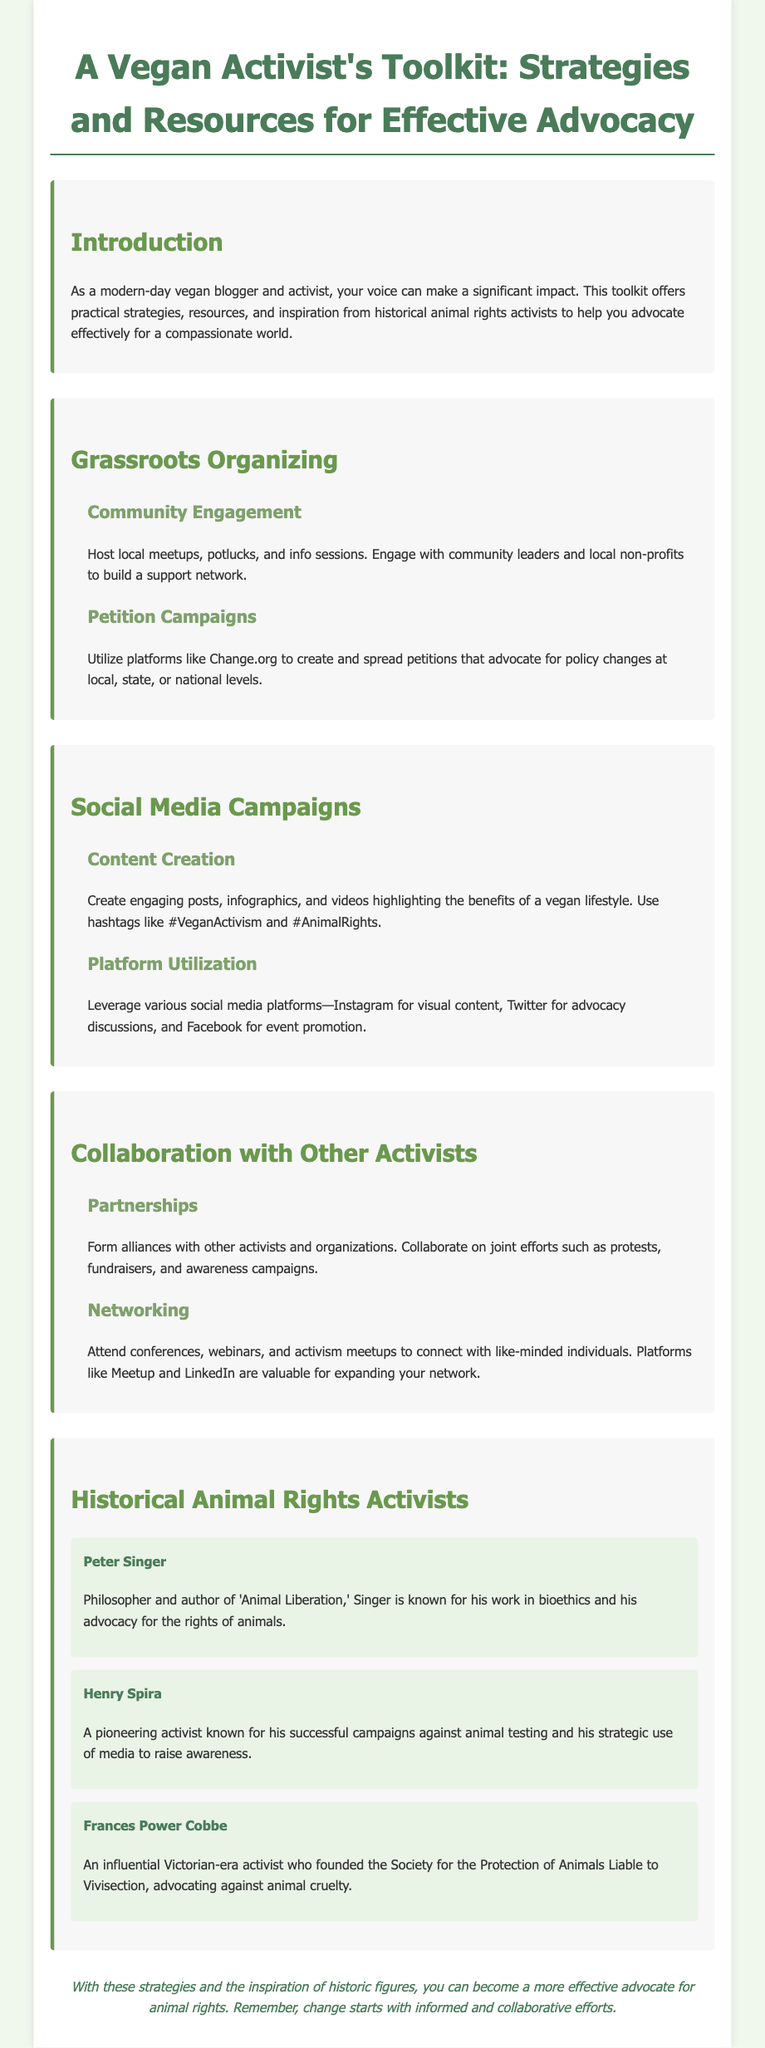What is the title of the toolkit? The title of the toolkit is presented in the main heading of the document.
Answer: A Vegan Activist's Toolkit: Strategies and Resources for Effective Advocacy Who is a noted philosopher associated with animal rights? The document lists Peter Singer as a significant figure advocating for animal rights.
Answer: Peter Singer What are two social media platforms mentioned? The document specifies platforms where activists can leverage their campaigns.
Answer: Instagram, Twitter What type of events should be hosted for community engagement? The document suggests hosting local meetups, which are essential for grassroots organizing.
Answer: Meetups How many historical activists are profiled in the document? The document provides profiles of three significant historical activists.
Answer: Three What color is primarily used for section headlines? The color code used for section headers is referenced in the style section of the document.
Answer: #6a994e Which platform is recommended for petition campaigns? The document recommends Change.org as a platform for advocacy petitions.
Answer: Change.org What approach did Henry Spira use in his activism? The document mentions media as a key strategy employed by Henry Spira in his campaigns.
Answer: Media 